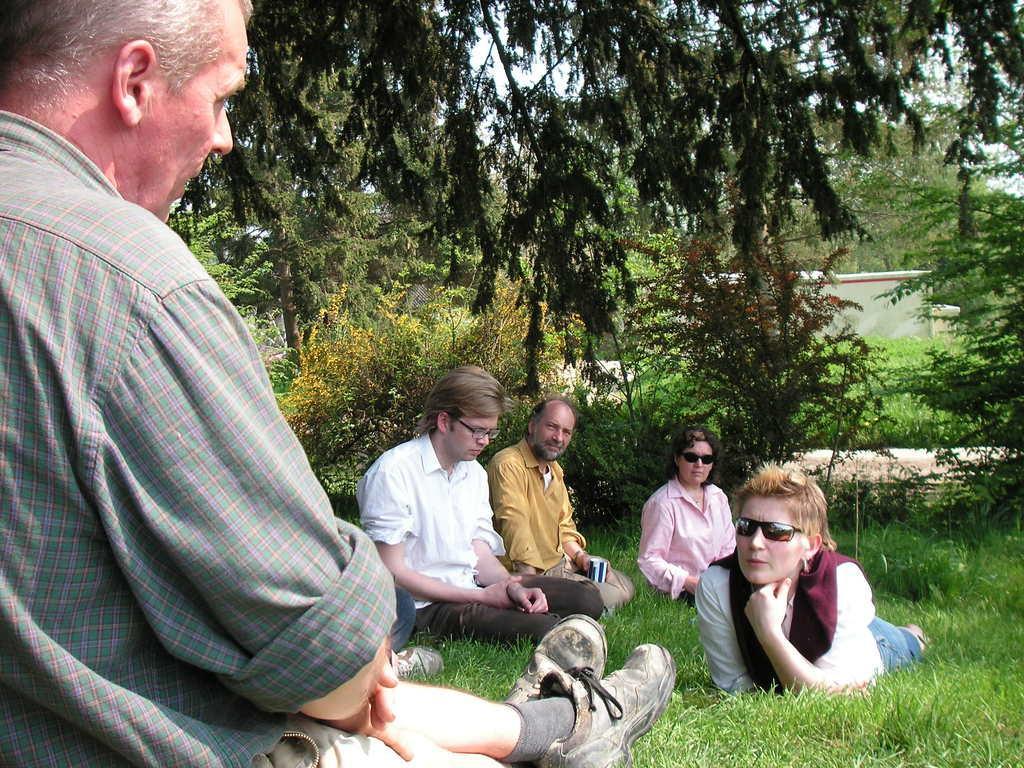In one or two sentences, can you explain what this image depicts? This picture describes about group of people, few people sitting on the grass and a woman is lying, in the background we can see few trees. 